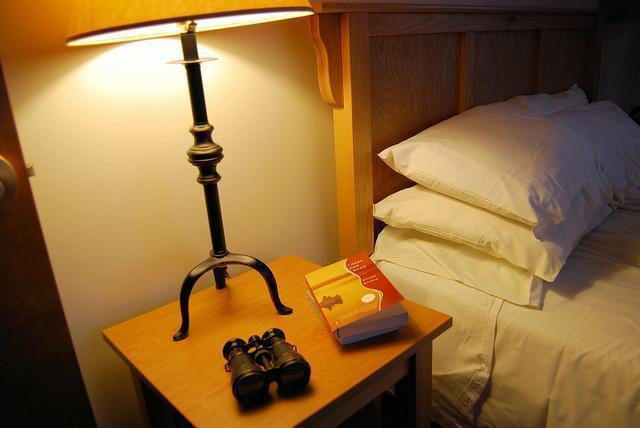How many pillows are there?
Give a very brief answer. 3. 